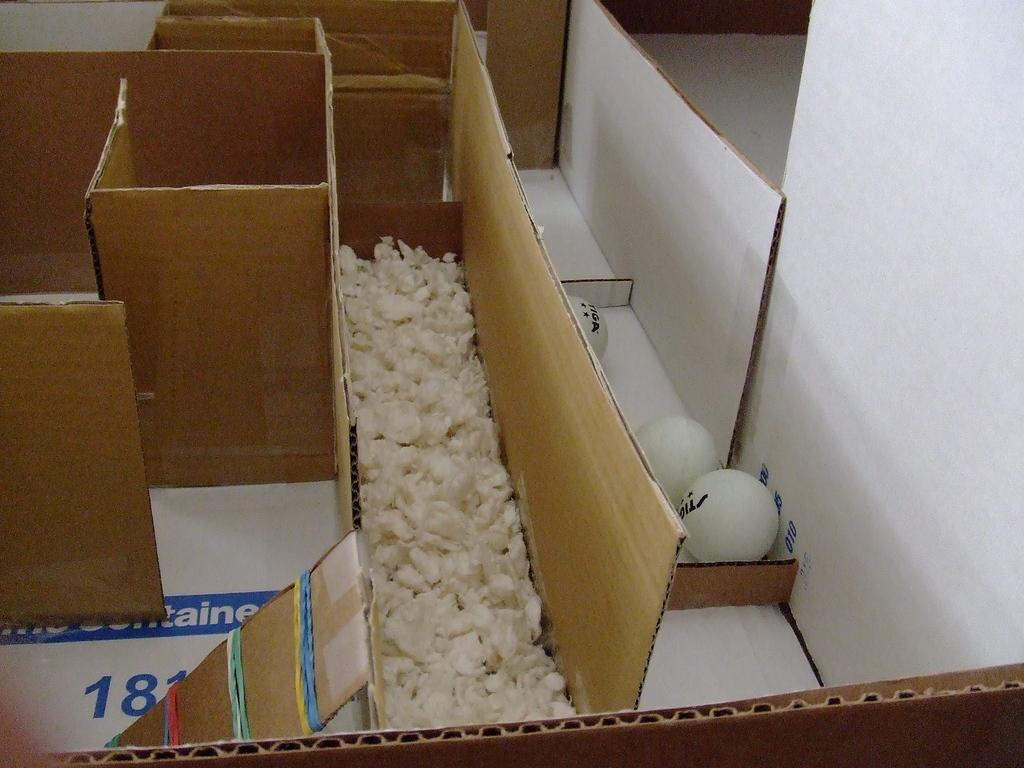<image>
Provide a brief description of the given image. The number 181 can be seen written on the cardboard in the maze made. 